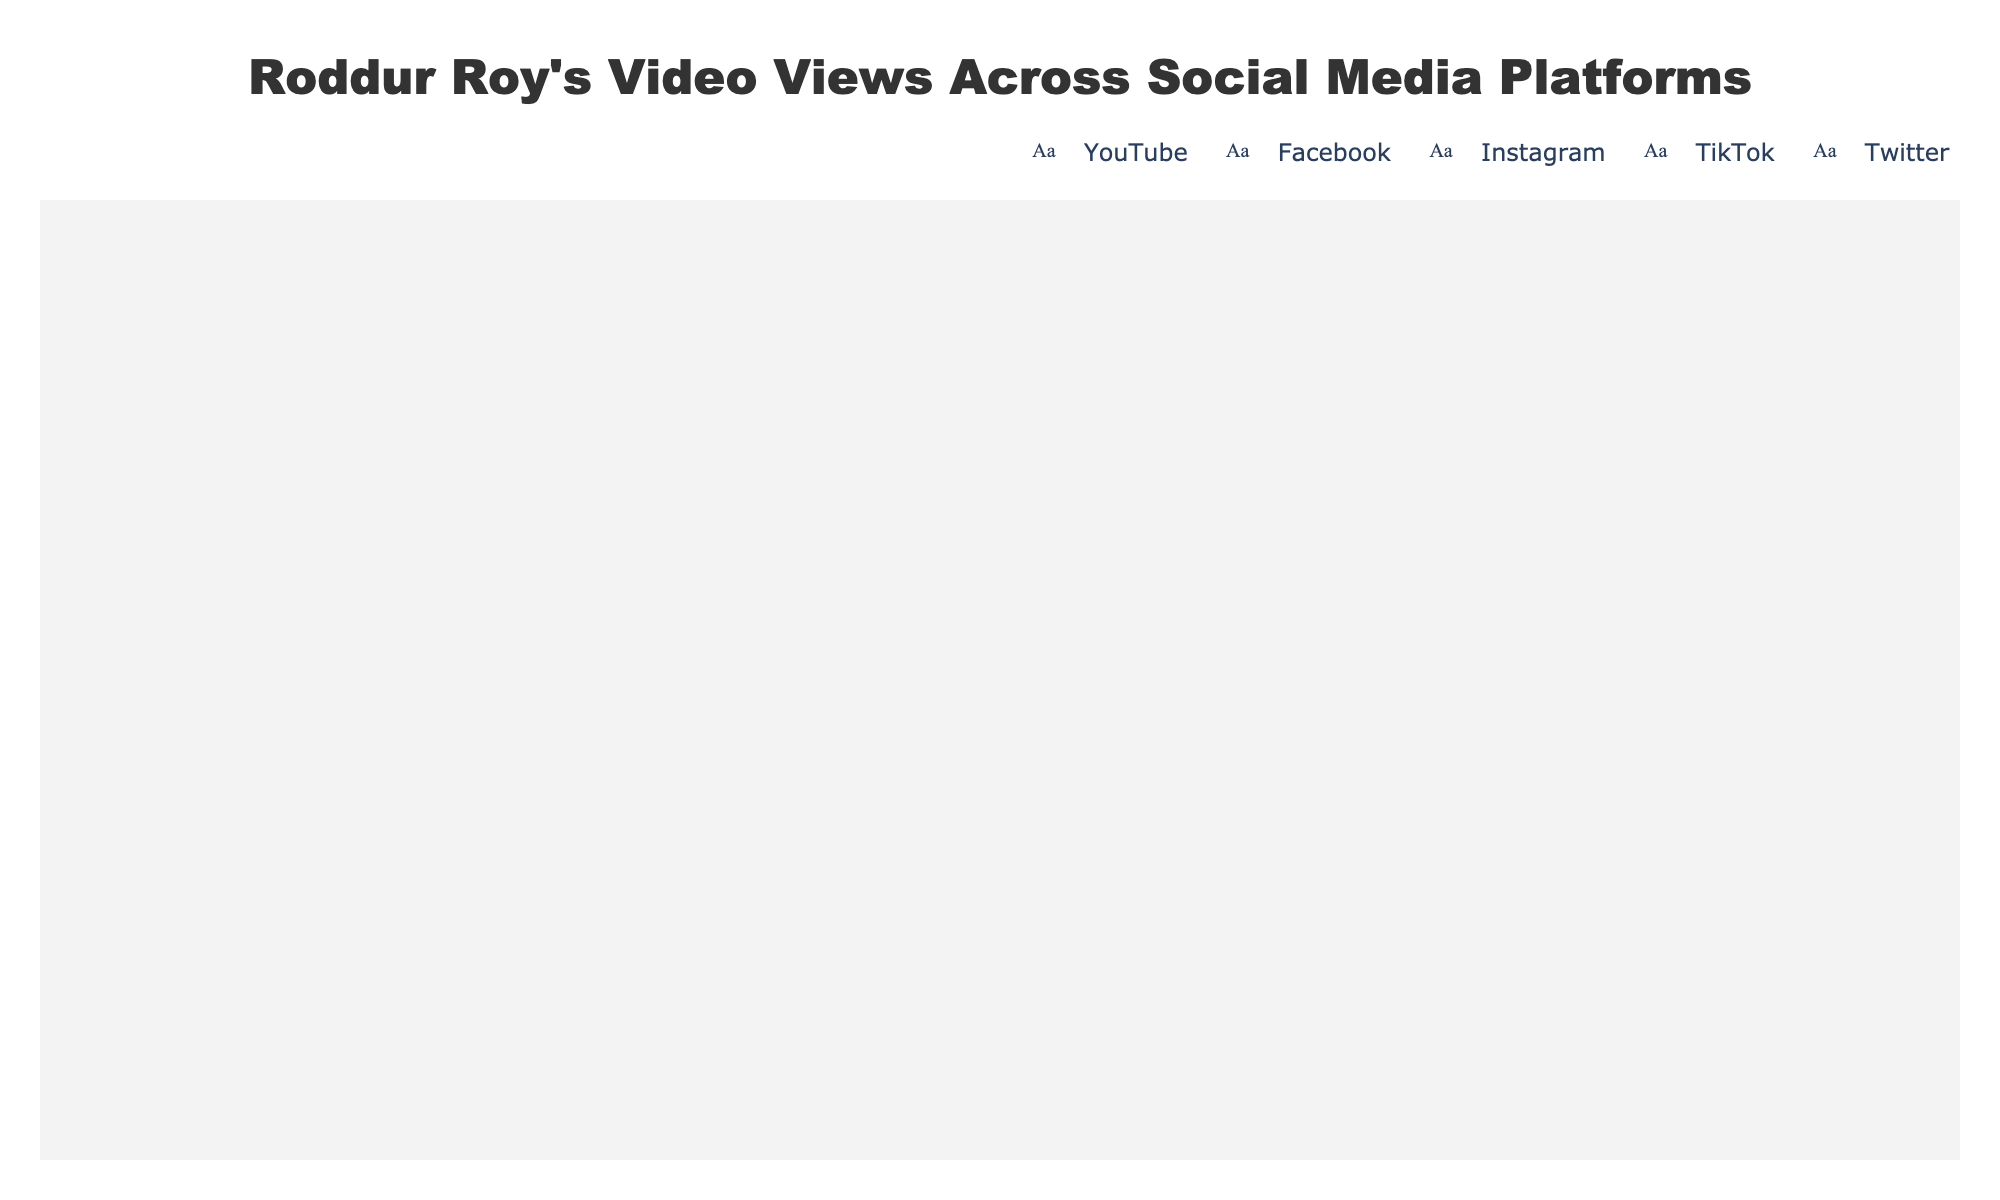Which social media platform has the most views for Roddur Roy's videos? The figure shows different numbers of icons representing views for each platform. YouTube has the most icons.
Answer: YouTube How many views does Roddur Roy get on TikTok? By looking at the hover text over the TikTok icons in the figure, it says "TikTok: 300,000 views".
Answer: 300,000 How many icons are used to represent views on Instagram? Each icon represents 50,000 views. Since Instagram has 500,000 views, dividing 500,000 by 50,000 tells us there are 10 icons.
Answer: 10 Which two platforms combined have the same number of views as YouTube alone? Adding views from different platforms: Facebook (750,000) + Instagram (500,000) = 1,250,000, which is close but more than 1,000,000 (YouTube), trying another: Instagram (500,000) + TikTok (300,000) = 800,000, still less. Facebook and Instagram together make 1,250,000. Hence, TikTok+Instagram give 800,000, Twitter+Instagram give 650,000.
Answer: None What is the difference in views between Facebook and Twitter? From the figure, Facebook's views are 750,000 and Twitter's are 150,000. The difference is found by subtracting Twitter's views from Facebook's views: 750,000 - 150,000 = 600,000.
Answer: 600,000 Rank the platforms from highest to lowest based on the views of Roddur Roy’s videos. Observing the icon counts: 
1. YouTube (1,000,000 views)
2. Facebook (750,000 views)
3. Instagram (500,000 views)
4. TikTok (300,000 views)
5. Twitter (150,000 views)
Answer: YouTube, Facebook, Instagram, TikTok, Twitter How many total views does Roddur Roy have across all platforms? Adding views from all platforms together: 1,000,000 (YouTube) + 750,000 (Facebook) + 500,000 (Instagram) + 300,000 (TikTok) + 150,000 (Twitter) = 2,700,000.
Answer: 2,700,000 Which platform has the least views for Roddur Roy's videos? The platform with the fewest icons is Twitter, which represents 150,000 views.
Answer: Twitter 